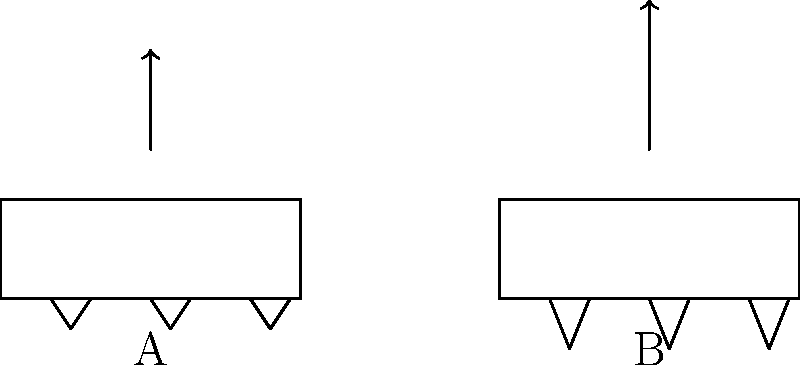Based on the diagram showing two different cleat designs (A and B), which design is likely to provide better acceleration for a player on a firm, grassy field? To determine which cleat design provides better acceleration, we need to consider the following factors:

1. Cleat length: Longer cleats (Design B) provide better traction by penetrating deeper into the ground.

2. Number of cleats: Both designs have the same number of cleats (3 per shoe).

3. Cleat distribution: Both designs have evenly distributed cleats along the shoe's length.

4. Arrow length: The arrow above Design B is longer, indicating greater acceleration.

5. Surface type: On a firm, grassy field, longer cleats can provide better grip without sinking too deep.

6. Force application: Longer cleats allow for more effective force transfer from the player's foot to the ground, resulting in improved acceleration.

7. Biomechanical efficiency: Design B's longer cleats enable the player to push off the ground more effectively, translating to better acceleration.

8. Stability: While longer cleats provide better acceleration, they may slightly reduce stability compared to shorter cleats.

Considering these factors, Design B with longer cleats is likely to provide better acceleration on a firm, grassy field due to improved traction and force transfer.
Answer: Design B 